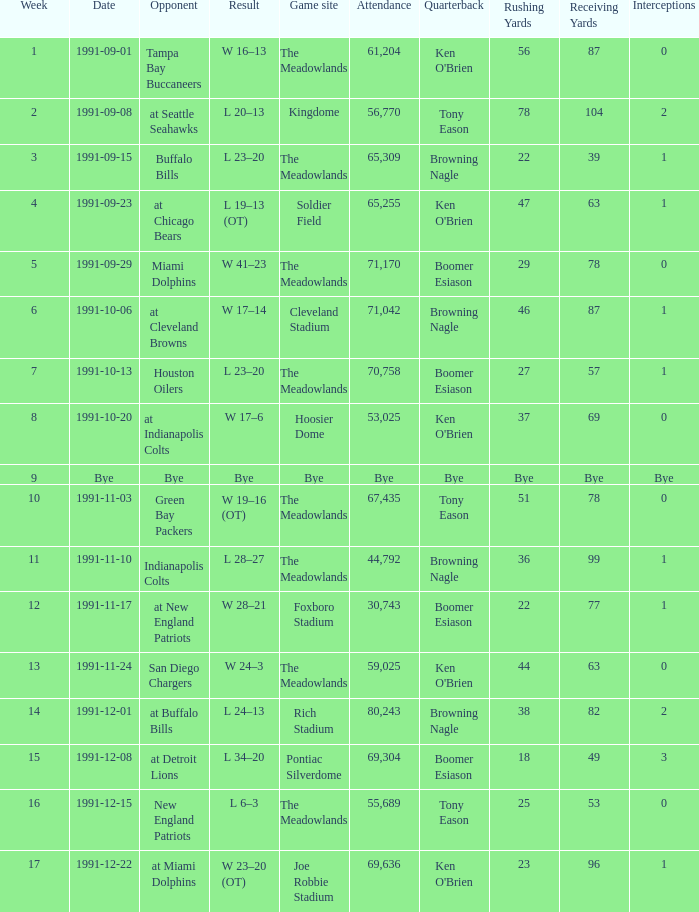What was the Result of the Game at the Meadowlands on 1991-09-01? W 16–13. 